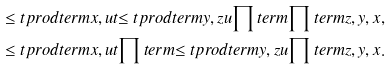Convert formula to latex. <formula><loc_0><loc_0><loc_500><loc_500>\leq t p r o d t e r m { x , u } { t } { \leq t p r o d t e r m { y , z } { u } { \prod t e r m { \prod t e r m { z , y } , x } } } , \\ \leq t p r o d t e r m { x , u } { t } { \prod t e r m { \leq t p r o d t e r m { y , z } { u } { \prod t e r m { z , y } } , x } } .</formula> 